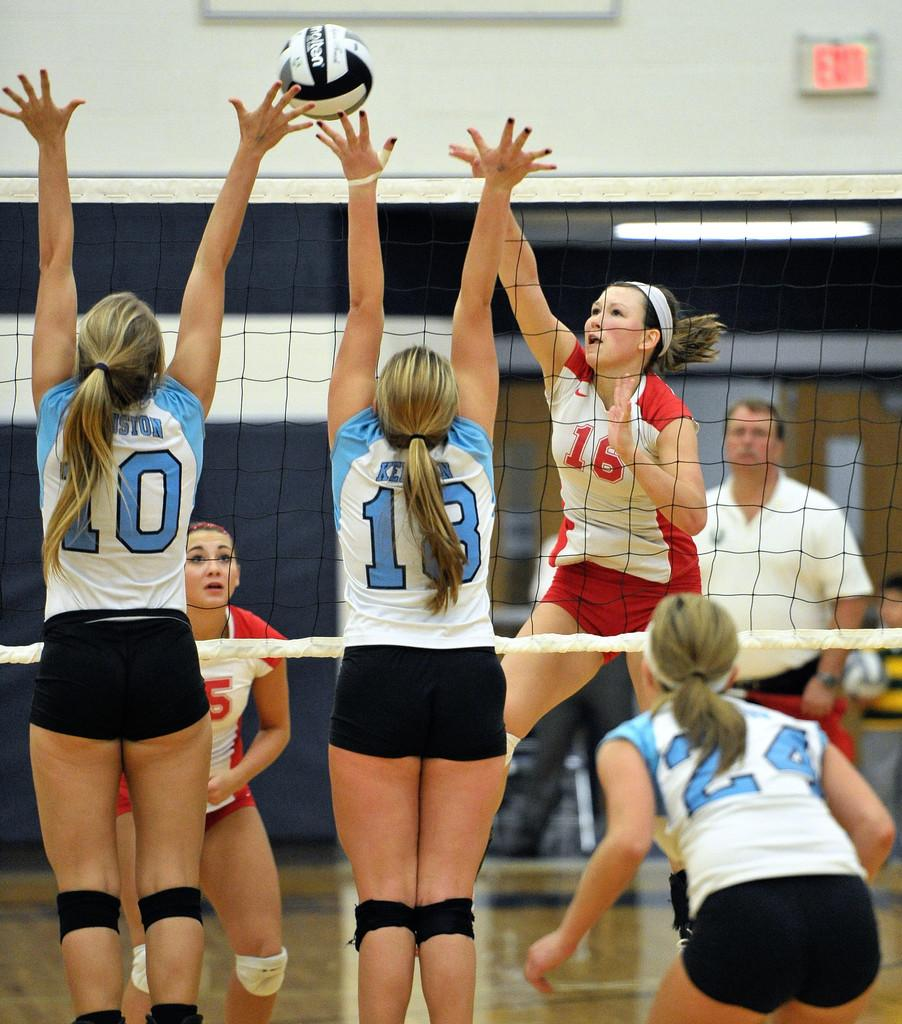Provide a one-sentence caption for the provided image. Girls playing volleyball with the numbers 10 and 18 about to hit the ball. 